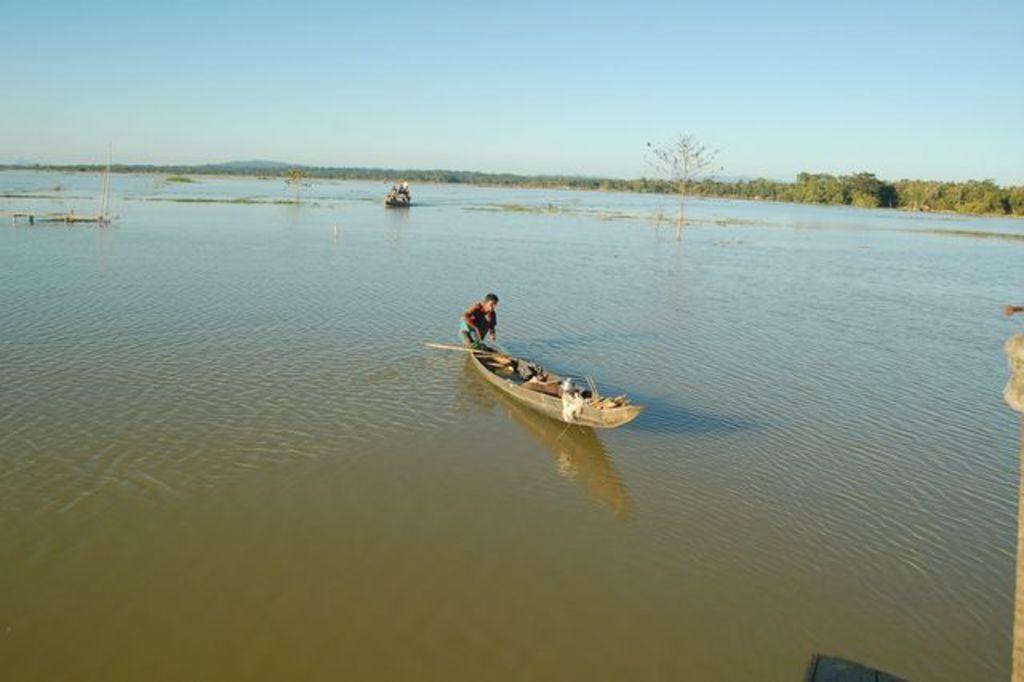How would you summarize this image in a sentence or two? In this picture we can see water at the bottom, there is a boat here, we can see a person in the boat, in the background there are some trees, we can see the sky at the top of the picture. 